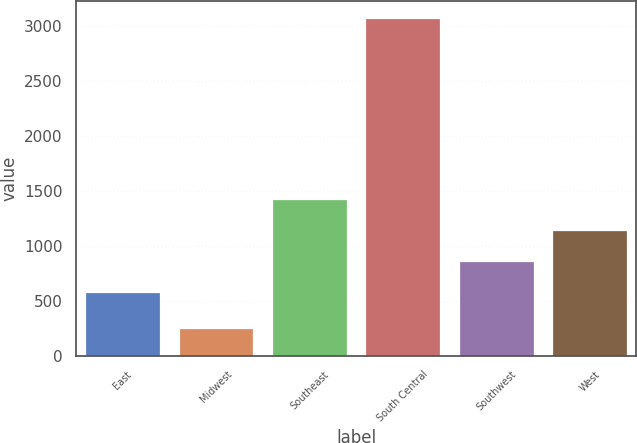Convert chart. <chart><loc_0><loc_0><loc_500><loc_500><bar_chart><fcel>East<fcel>Midwest<fcel>Southeast<fcel>South Central<fcel>Southwest<fcel>West<nl><fcel>581<fcel>250<fcel>1428.8<fcel>3076<fcel>863.6<fcel>1146.2<nl></chart> 